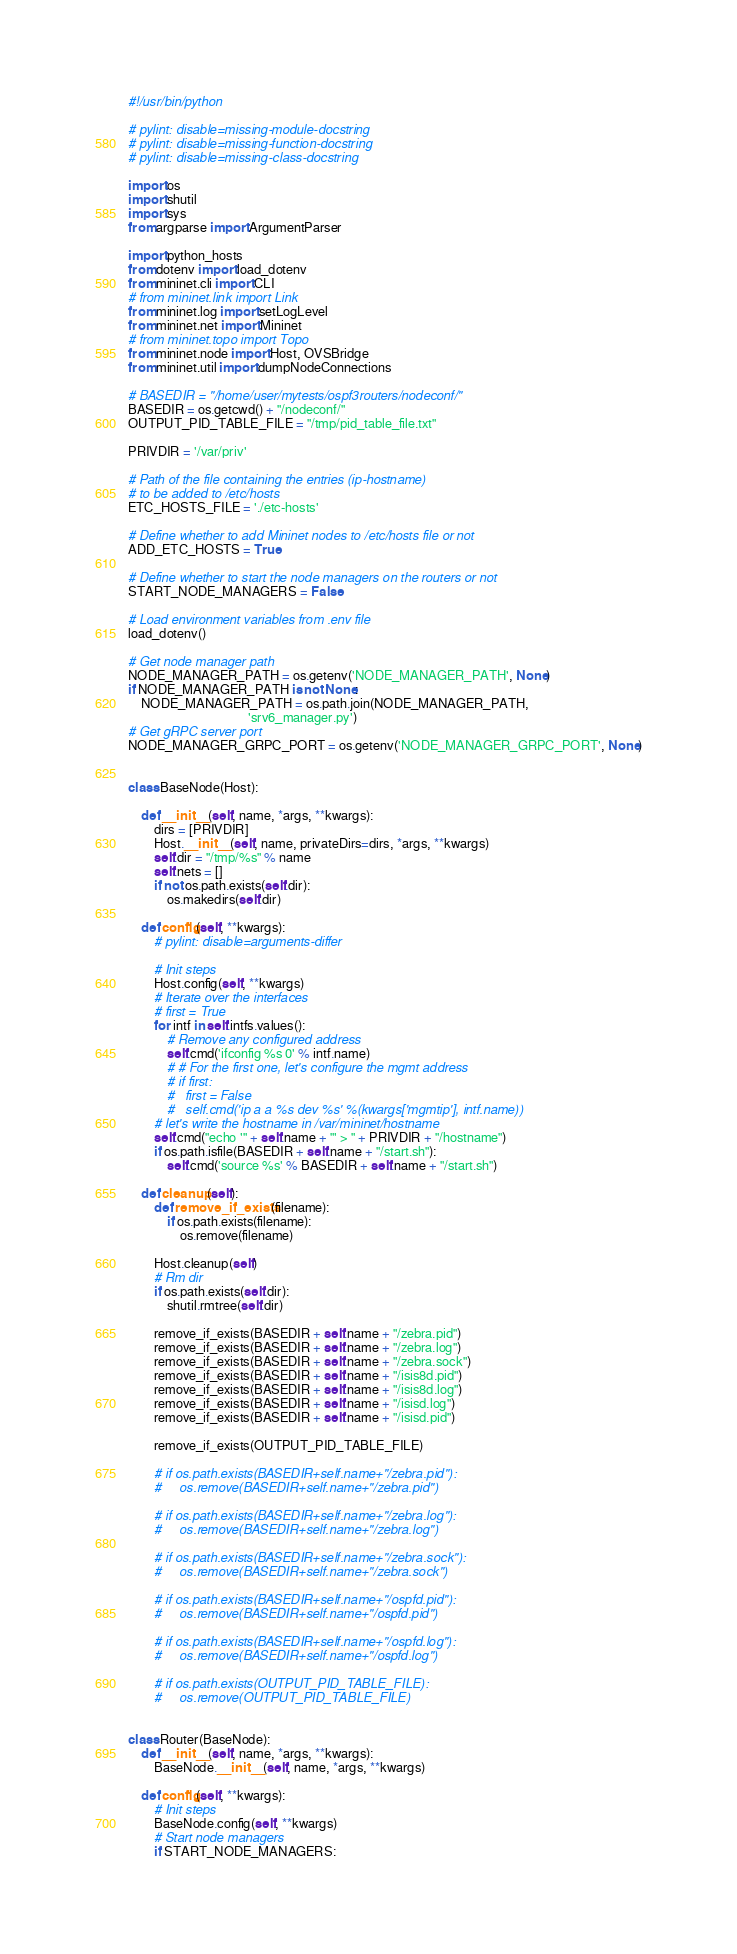<code> <loc_0><loc_0><loc_500><loc_500><_Python_>#!/usr/bin/python

# pylint: disable=missing-module-docstring
# pylint: disable=missing-function-docstring
# pylint: disable=missing-class-docstring

import os
import shutil
import sys
from argparse import ArgumentParser

import python_hosts
from dotenv import load_dotenv
from mininet.cli import CLI
# from mininet.link import Link
from mininet.log import setLogLevel
from mininet.net import Mininet
# from mininet.topo import Topo
from mininet.node import Host, OVSBridge
from mininet.util import dumpNodeConnections

# BASEDIR = "/home/user/mytests/ospf3routers/nodeconf/"
BASEDIR = os.getcwd() + "/nodeconf/"
OUTPUT_PID_TABLE_FILE = "/tmp/pid_table_file.txt"

PRIVDIR = '/var/priv'

# Path of the file containing the entries (ip-hostname)
# to be added to /etc/hosts
ETC_HOSTS_FILE = './etc-hosts'

# Define whether to add Mininet nodes to /etc/hosts file or not
ADD_ETC_HOSTS = True

# Define whether to start the node managers on the routers or not
START_NODE_MANAGERS = False

# Load environment variables from .env file
load_dotenv()

# Get node manager path
NODE_MANAGER_PATH = os.getenv('NODE_MANAGER_PATH', None)
if NODE_MANAGER_PATH is not None:
    NODE_MANAGER_PATH = os.path.join(NODE_MANAGER_PATH,
                                     'srv6_manager.py')
# Get gRPC server port
NODE_MANAGER_GRPC_PORT = os.getenv('NODE_MANAGER_GRPC_PORT', None)


class BaseNode(Host):

    def __init__(self, name, *args, **kwargs):
        dirs = [PRIVDIR]
        Host.__init__(self, name, privateDirs=dirs, *args, **kwargs)
        self.dir = "/tmp/%s" % name
        self.nets = []
        if not os.path.exists(self.dir):
            os.makedirs(self.dir)

    def config(self, **kwargs):
        # pylint: disable=arguments-differ

        # Init steps
        Host.config(self, **kwargs)
        # Iterate over the interfaces
        # first = True
        for intf in self.intfs.values():
            # Remove any configured address
            self.cmd('ifconfig %s 0' % intf.name)
            # # For the first one, let's configure the mgmt address
            # if first:
            #   first = False
            #   self.cmd('ip a a %s dev %s' %(kwargs['mgmtip'], intf.name))
        # let's write the hostname in /var/mininet/hostname
        self.cmd("echo '" + self.name + "' > " + PRIVDIR + "/hostname")
        if os.path.isfile(BASEDIR + self.name + "/start.sh"):
            self.cmd('source %s' % BASEDIR + self.name + "/start.sh")

    def cleanup(self):
        def remove_if_exists(filename):
            if os.path.exists(filename):
                os.remove(filename)

        Host.cleanup(self)
        # Rm dir
        if os.path.exists(self.dir):
            shutil.rmtree(self.dir)

        remove_if_exists(BASEDIR + self.name + "/zebra.pid")
        remove_if_exists(BASEDIR + self.name + "/zebra.log")
        remove_if_exists(BASEDIR + self.name + "/zebra.sock")
        remove_if_exists(BASEDIR + self.name + "/isis8d.pid")
        remove_if_exists(BASEDIR + self.name + "/isis8d.log")
        remove_if_exists(BASEDIR + self.name + "/isisd.log")
        remove_if_exists(BASEDIR + self.name + "/isisd.pid")

        remove_if_exists(OUTPUT_PID_TABLE_FILE)

        # if os.path.exists(BASEDIR+self.name+"/zebra.pid"):
        #     os.remove(BASEDIR+self.name+"/zebra.pid")

        # if os.path.exists(BASEDIR+self.name+"/zebra.log"):
        #     os.remove(BASEDIR+self.name+"/zebra.log")

        # if os.path.exists(BASEDIR+self.name+"/zebra.sock"):
        #     os.remove(BASEDIR+self.name+"/zebra.sock")

        # if os.path.exists(BASEDIR+self.name+"/ospfd.pid"):
        #     os.remove(BASEDIR+self.name+"/ospfd.pid")

        # if os.path.exists(BASEDIR+self.name+"/ospfd.log"):
        #     os.remove(BASEDIR+self.name+"/ospfd.log")

        # if os.path.exists(OUTPUT_PID_TABLE_FILE):
        #     os.remove(OUTPUT_PID_TABLE_FILE)


class Router(BaseNode):
    def __init__(self, name, *args, **kwargs):
        BaseNode.__init__(self, name, *args, **kwargs)

    def config(self, **kwargs):
        # Init steps
        BaseNode.config(self, **kwargs)
        # Start node managers
        if START_NODE_MANAGERS:</code> 